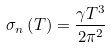Convert formula to latex. <formula><loc_0><loc_0><loc_500><loc_500>\sigma _ { n } \left ( T \right ) = \frac { \gamma T ^ { 3 } } { 2 \pi ^ { 2 } }</formula> 